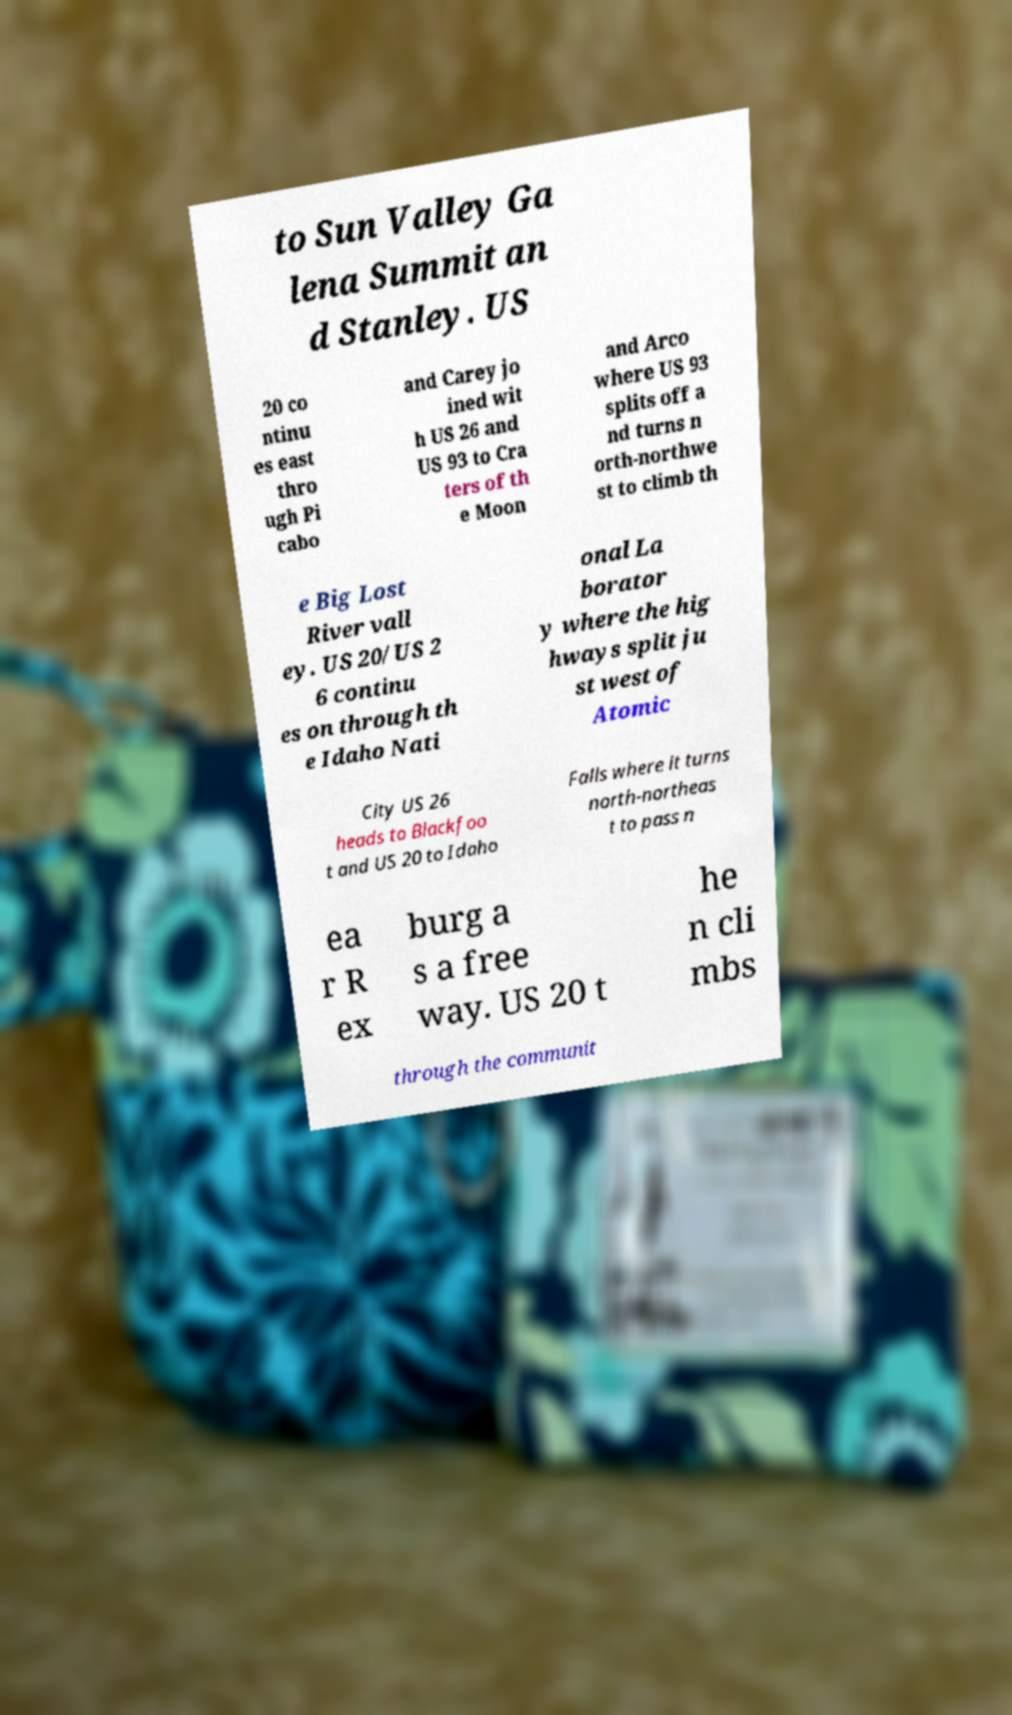For documentation purposes, I need the text within this image transcribed. Could you provide that? to Sun Valley Ga lena Summit an d Stanley. US 20 co ntinu es east thro ugh Pi cabo and Carey jo ined wit h US 26 and US 93 to Cra ters of th e Moon and Arco where US 93 splits off a nd turns n orth-northwe st to climb th e Big Lost River vall ey. US 20/US 2 6 continu es on through th e Idaho Nati onal La borator y where the hig hways split ju st west of Atomic City US 26 heads to Blackfoo t and US 20 to Idaho Falls where it turns north-northeas t to pass n ea r R ex burg a s a free way. US 20 t he n cli mbs through the communit 